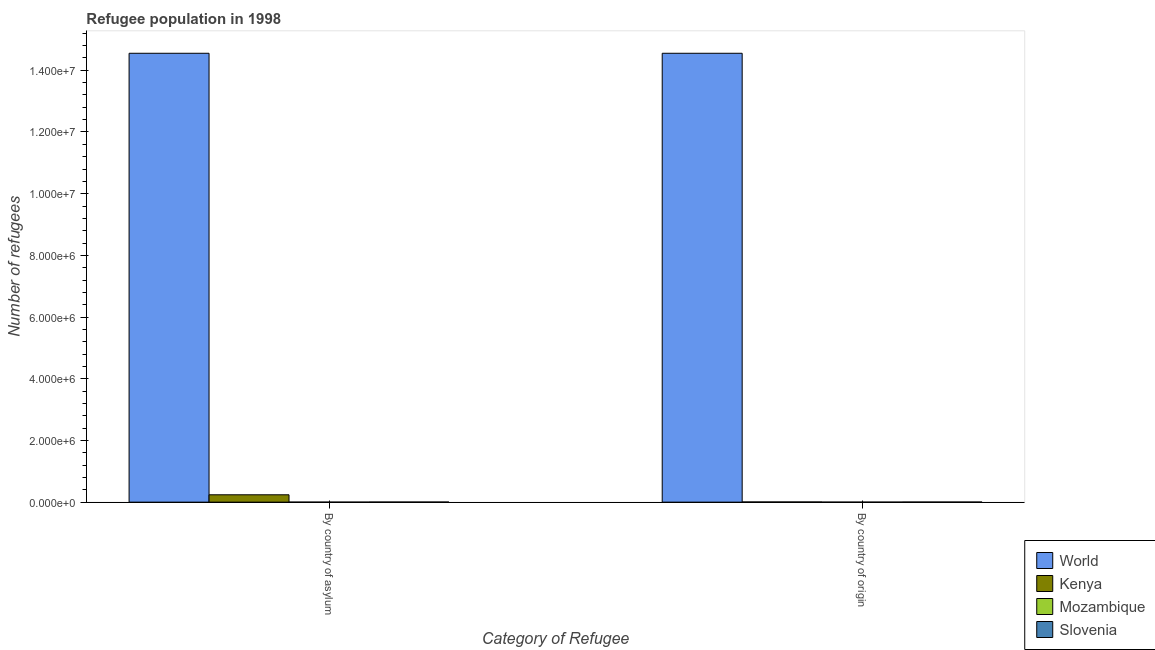How many different coloured bars are there?
Keep it short and to the point. 4. Are the number of bars on each tick of the X-axis equal?
Provide a short and direct response. Yes. How many bars are there on the 2nd tick from the left?
Offer a very short reply. 4. What is the label of the 2nd group of bars from the left?
Provide a short and direct response. By country of origin. What is the number of refugees by country of asylum in Kenya?
Keep it short and to the point. 2.38e+05. Across all countries, what is the maximum number of refugees by country of origin?
Your answer should be very brief. 1.46e+07. Across all countries, what is the minimum number of refugees by country of origin?
Provide a short and direct response. 59. In which country was the number of refugees by country of origin minimum?
Your answer should be compact. Mozambique. What is the total number of refugees by country of asylum in the graph?
Provide a succinct answer. 1.48e+07. What is the difference between the number of refugees by country of asylum in World and that in Mozambique?
Your response must be concise. 1.46e+07. What is the difference between the number of refugees by country of origin in Slovenia and the number of refugees by country of asylum in World?
Your answer should be compact. -1.45e+07. What is the average number of refugees by country of asylum per country?
Your answer should be very brief. 3.70e+06. What is the difference between the number of refugees by country of origin and number of refugees by country of asylum in Mozambique?
Ensure brevity in your answer.  7. What is the ratio of the number of refugees by country of origin in Mozambique to that in Kenya?
Provide a succinct answer. 0.01. Is the number of refugees by country of asylum in Kenya less than that in Mozambique?
Your answer should be very brief. No. What does the 3rd bar from the right in By country of origin represents?
Ensure brevity in your answer.  Kenya. What is the difference between two consecutive major ticks on the Y-axis?
Offer a very short reply. 2.00e+06. What is the title of the graph?
Your response must be concise. Refugee population in 1998. Does "Benin" appear as one of the legend labels in the graph?
Offer a terse response. No. What is the label or title of the X-axis?
Ensure brevity in your answer.  Category of Refugee. What is the label or title of the Y-axis?
Your answer should be compact. Number of refugees. What is the Number of refugees in World in By country of asylum?
Your answer should be very brief. 1.46e+07. What is the Number of refugees in Kenya in By country of asylum?
Ensure brevity in your answer.  2.38e+05. What is the Number of refugees in Slovenia in By country of asylum?
Give a very brief answer. 3465. What is the Number of refugees in World in By country of origin?
Ensure brevity in your answer.  1.46e+07. What is the Number of refugees of Kenya in By country of origin?
Offer a terse response. 6046. What is the Number of refugees in Slovenia in By country of origin?
Give a very brief answer. 3302. Across all Category of Refugee, what is the maximum Number of refugees in World?
Provide a succinct answer. 1.46e+07. Across all Category of Refugee, what is the maximum Number of refugees in Kenya?
Ensure brevity in your answer.  2.38e+05. Across all Category of Refugee, what is the maximum Number of refugees in Mozambique?
Give a very brief answer. 59. Across all Category of Refugee, what is the maximum Number of refugees in Slovenia?
Provide a succinct answer. 3465. Across all Category of Refugee, what is the minimum Number of refugees in World?
Ensure brevity in your answer.  1.46e+07. Across all Category of Refugee, what is the minimum Number of refugees in Kenya?
Your response must be concise. 6046. Across all Category of Refugee, what is the minimum Number of refugees in Mozambique?
Offer a very short reply. 52. Across all Category of Refugee, what is the minimum Number of refugees of Slovenia?
Provide a succinct answer. 3302. What is the total Number of refugees in World in the graph?
Ensure brevity in your answer.  2.91e+07. What is the total Number of refugees in Kenya in the graph?
Offer a very short reply. 2.44e+05. What is the total Number of refugees in Mozambique in the graph?
Provide a short and direct response. 111. What is the total Number of refugees in Slovenia in the graph?
Keep it short and to the point. 6767. What is the difference between the Number of refugees of Kenya in By country of asylum and that in By country of origin?
Give a very brief answer. 2.32e+05. What is the difference between the Number of refugees of Slovenia in By country of asylum and that in By country of origin?
Make the answer very short. 163. What is the difference between the Number of refugees in World in By country of asylum and the Number of refugees in Kenya in By country of origin?
Offer a very short reply. 1.45e+07. What is the difference between the Number of refugees in World in By country of asylum and the Number of refugees in Mozambique in By country of origin?
Your answer should be very brief. 1.46e+07. What is the difference between the Number of refugees in World in By country of asylum and the Number of refugees in Slovenia in By country of origin?
Make the answer very short. 1.45e+07. What is the difference between the Number of refugees in Kenya in By country of asylum and the Number of refugees in Mozambique in By country of origin?
Provide a short and direct response. 2.38e+05. What is the difference between the Number of refugees of Kenya in By country of asylum and the Number of refugees of Slovenia in By country of origin?
Provide a succinct answer. 2.35e+05. What is the difference between the Number of refugees in Mozambique in By country of asylum and the Number of refugees in Slovenia in By country of origin?
Your response must be concise. -3250. What is the average Number of refugees in World per Category of Refugee?
Keep it short and to the point. 1.46e+07. What is the average Number of refugees of Kenya per Category of Refugee?
Provide a succinct answer. 1.22e+05. What is the average Number of refugees in Mozambique per Category of Refugee?
Your answer should be very brief. 55.5. What is the average Number of refugees in Slovenia per Category of Refugee?
Ensure brevity in your answer.  3383.5. What is the difference between the Number of refugees in World and Number of refugees in Kenya in By country of asylum?
Keep it short and to the point. 1.43e+07. What is the difference between the Number of refugees of World and Number of refugees of Mozambique in By country of asylum?
Your answer should be very brief. 1.46e+07. What is the difference between the Number of refugees in World and Number of refugees in Slovenia in By country of asylum?
Your answer should be very brief. 1.45e+07. What is the difference between the Number of refugees of Kenya and Number of refugees of Mozambique in By country of asylum?
Your answer should be very brief. 2.38e+05. What is the difference between the Number of refugees of Kenya and Number of refugees of Slovenia in By country of asylum?
Your answer should be very brief. 2.35e+05. What is the difference between the Number of refugees in Mozambique and Number of refugees in Slovenia in By country of asylum?
Give a very brief answer. -3413. What is the difference between the Number of refugees in World and Number of refugees in Kenya in By country of origin?
Offer a very short reply. 1.45e+07. What is the difference between the Number of refugees of World and Number of refugees of Mozambique in By country of origin?
Your answer should be compact. 1.46e+07. What is the difference between the Number of refugees in World and Number of refugees in Slovenia in By country of origin?
Ensure brevity in your answer.  1.45e+07. What is the difference between the Number of refugees of Kenya and Number of refugees of Mozambique in By country of origin?
Provide a short and direct response. 5987. What is the difference between the Number of refugees in Kenya and Number of refugees in Slovenia in By country of origin?
Make the answer very short. 2744. What is the difference between the Number of refugees in Mozambique and Number of refugees in Slovenia in By country of origin?
Ensure brevity in your answer.  -3243. What is the ratio of the Number of refugees of Kenya in By country of asylum to that in By country of origin?
Provide a short and direct response. 39.4. What is the ratio of the Number of refugees of Mozambique in By country of asylum to that in By country of origin?
Offer a very short reply. 0.88. What is the ratio of the Number of refugees of Slovenia in By country of asylum to that in By country of origin?
Offer a very short reply. 1.05. What is the difference between the highest and the second highest Number of refugees in Kenya?
Make the answer very short. 2.32e+05. What is the difference between the highest and the second highest Number of refugees in Mozambique?
Offer a terse response. 7. What is the difference between the highest and the second highest Number of refugees in Slovenia?
Your answer should be very brief. 163. What is the difference between the highest and the lowest Number of refugees in World?
Keep it short and to the point. 0. What is the difference between the highest and the lowest Number of refugees in Kenya?
Keep it short and to the point. 2.32e+05. What is the difference between the highest and the lowest Number of refugees in Slovenia?
Provide a succinct answer. 163. 